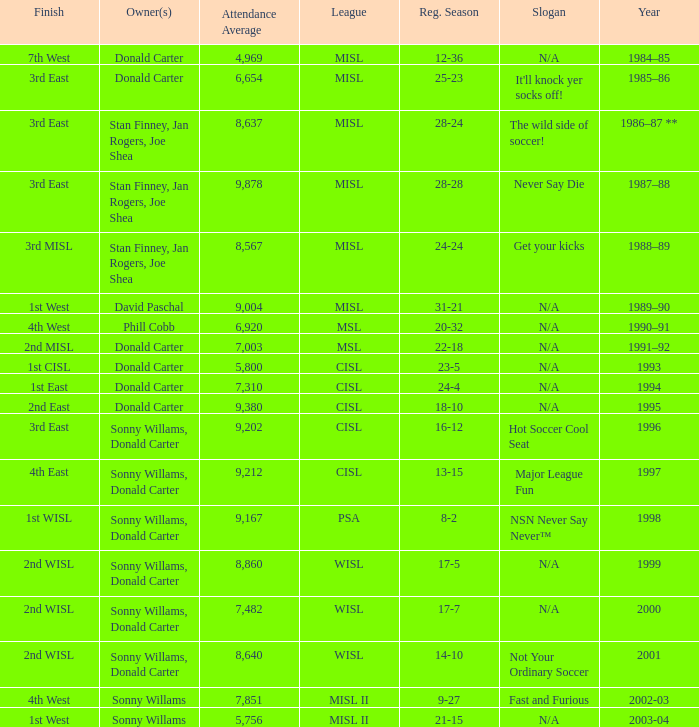What year has the wild side of soccer! as the slogan? 1986–87 **. 